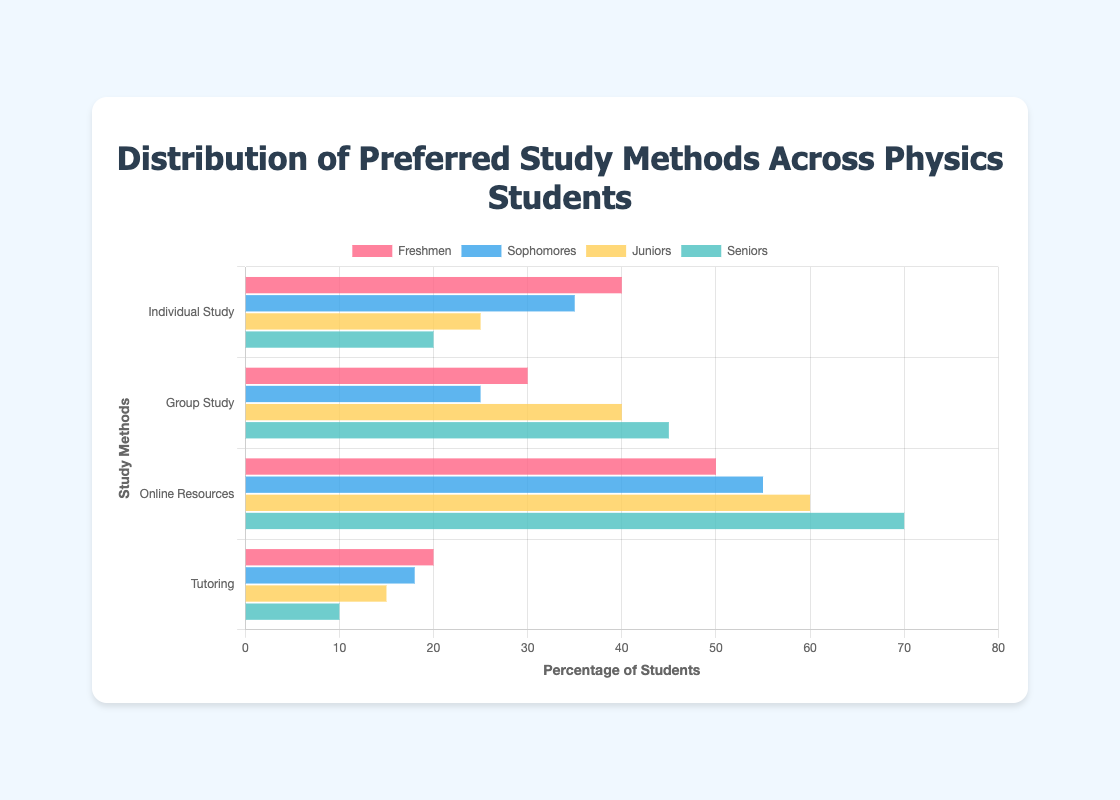What is the most preferred study method among seniors? By observing the lengths of the bars for Seniors, the 'Online Resources' bar is the longest. Thus, the most preferred study method among seniors is Online Resources.
Answer: Online Resources Which class has the least preference for individual study? By comparing the lengths of the 'Individual Study' bars for each class, the Seniors have the shortest bar at 20.
Answer: Seniors How many more juniors prefer group study compared to individual study? The 'Group Study' bar for Juniors is at 40, and the 'Individual Study' bar is at 25. The difference is 40 - 25 = 15.
Answer: 15 What’s the sum of senior students who prefer online resources and tutoring? The 'Online Resources' bar for Seniors shows 70, and the 'Tutoring' bar shows 10. The sum is 70 + 10 = 80.
Answer: 80 For which study method do Freshmen have the highest preference? By comparing the lengths of all bars for Freshmen, 'Online Resources' has the longest bar at 50.
Answer: Online Resources Which class shows the most consistent(preference) across all study methods? Consistency can be gauged by looking at similar bar lengths for all categories in a class. Freshmen have the most consistent preference as their bars are close in length without extreme highs or lows.
Answer: Freshmen What is the difference between Juniors and Sophomores using online resources? The 'Online Resources' bar for Juniors is at 60, and for Sophomores, it's at 55. The difference is 60 - 55 = 5.
Answer: 5 Which study method has the lowest preference among Sophomores? The shortest bar for Sophomores is for 'Tutoring' at 18.
Answer: Tutoring 